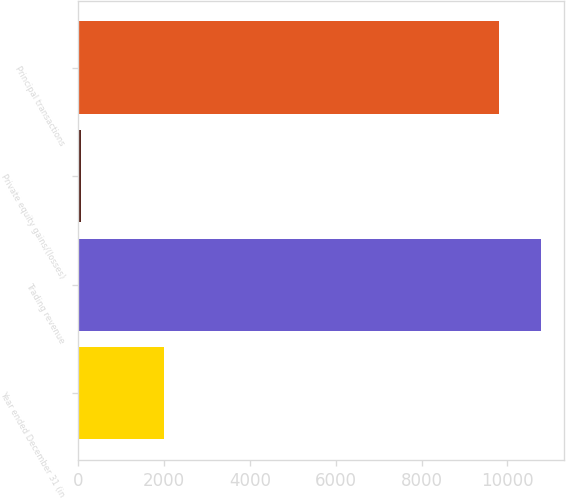<chart> <loc_0><loc_0><loc_500><loc_500><bar_chart><fcel>Year ended December 31 (in<fcel>Trading revenue<fcel>Private equity gains/(losses)<fcel>Principal transactions<nl><fcel>2009<fcel>10775.6<fcel>74<fcel>9796<nl></chart> 